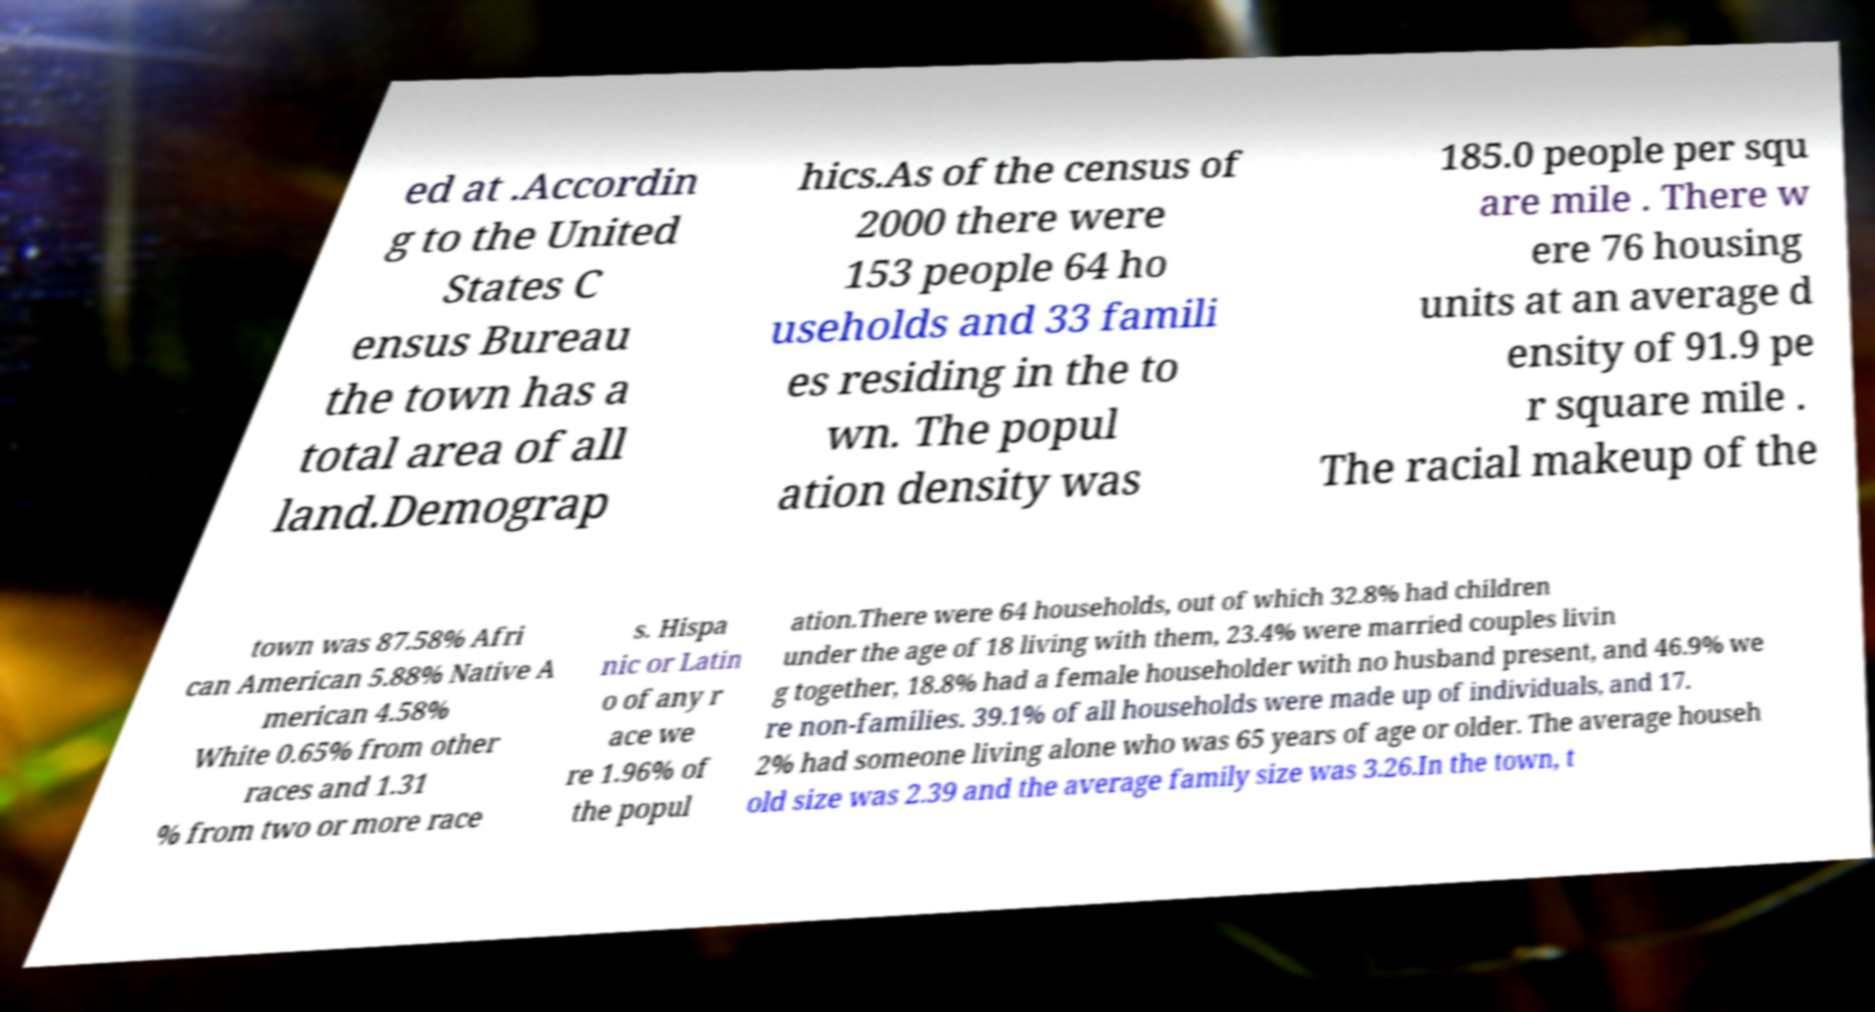For documentation purposes, I need the text within this image transcribed. Could you provide that? ed at .Accordin g to the United States C ensus Bureau the town has a total area of all land.Demograp hics.As of the census of 2000 there were 153 people 64 ho useholds and 33 famili es residing in the to wn. The popul ation density was 185.0 people per squ are mile . There w ere 76 housing units at an average d ensity of 91.9 pe r square mile . The racial makeup of the town was 87.58% Afri can American 5.88% Native A merican 4.58% White 0.65% from other races and 1.31 % from two or more race s. Hispa nic or Latin o of any r ace we re 1.96% of the popul ation.There were 64 households, out of which 32.8% had children under the age of 18 living with them, 23.4% were married couples livin g together, 18.8% had a female householder with no husband present, and 46.9% we re non-families. 39.1% of all households were made up of individuals, and 17. 2% had someone living alone who was 65 years of age or older. The average househ old size was 2.39 and the average family size was 3.26.In the town, t 